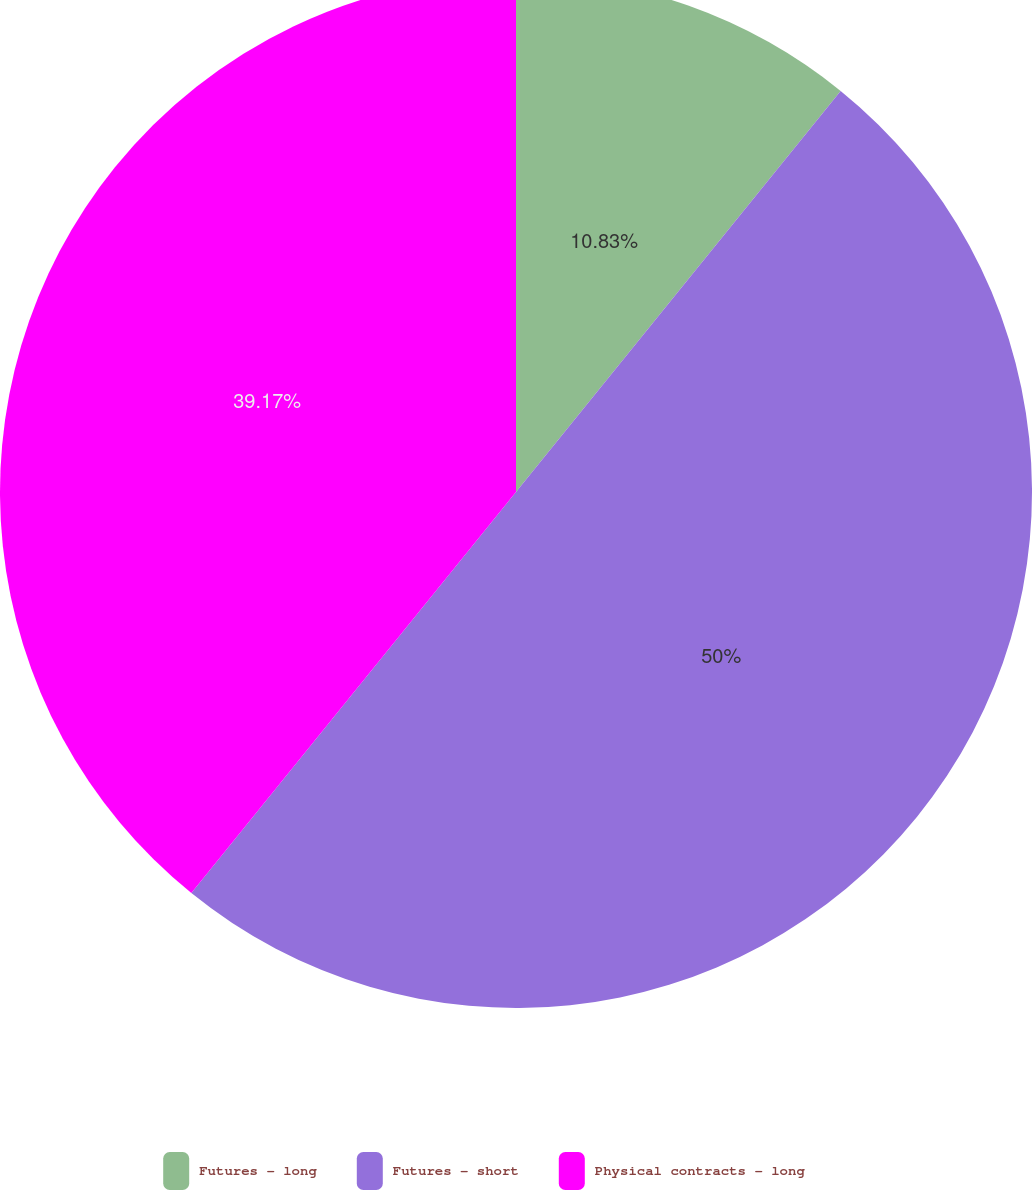Convert chart to OTSL. <chart><loc_0><loc_0><loc_500><loc_500><pie_chart><fcel>Futures - long<fcel>Futures - short<fcel>Physical contracts - long<nl><fcel>10.83%<fcel>50.0%<fcel>39.17%<nl></chart> 